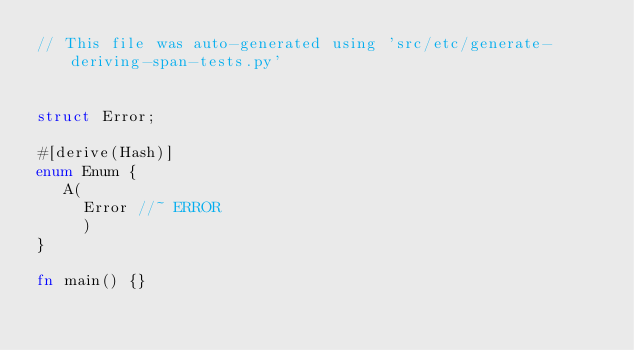<code> <loc_0><loc_0><loc_500><loc_500><_Rust_>// This file was auto-generated using 'src/etc/generate-deriving-span-tests.py'


struct Error;

#[derive(Hash)]
enum Enum {
   A(
     Error //~ ERROR
     )
}

fn main() {}
</code> 